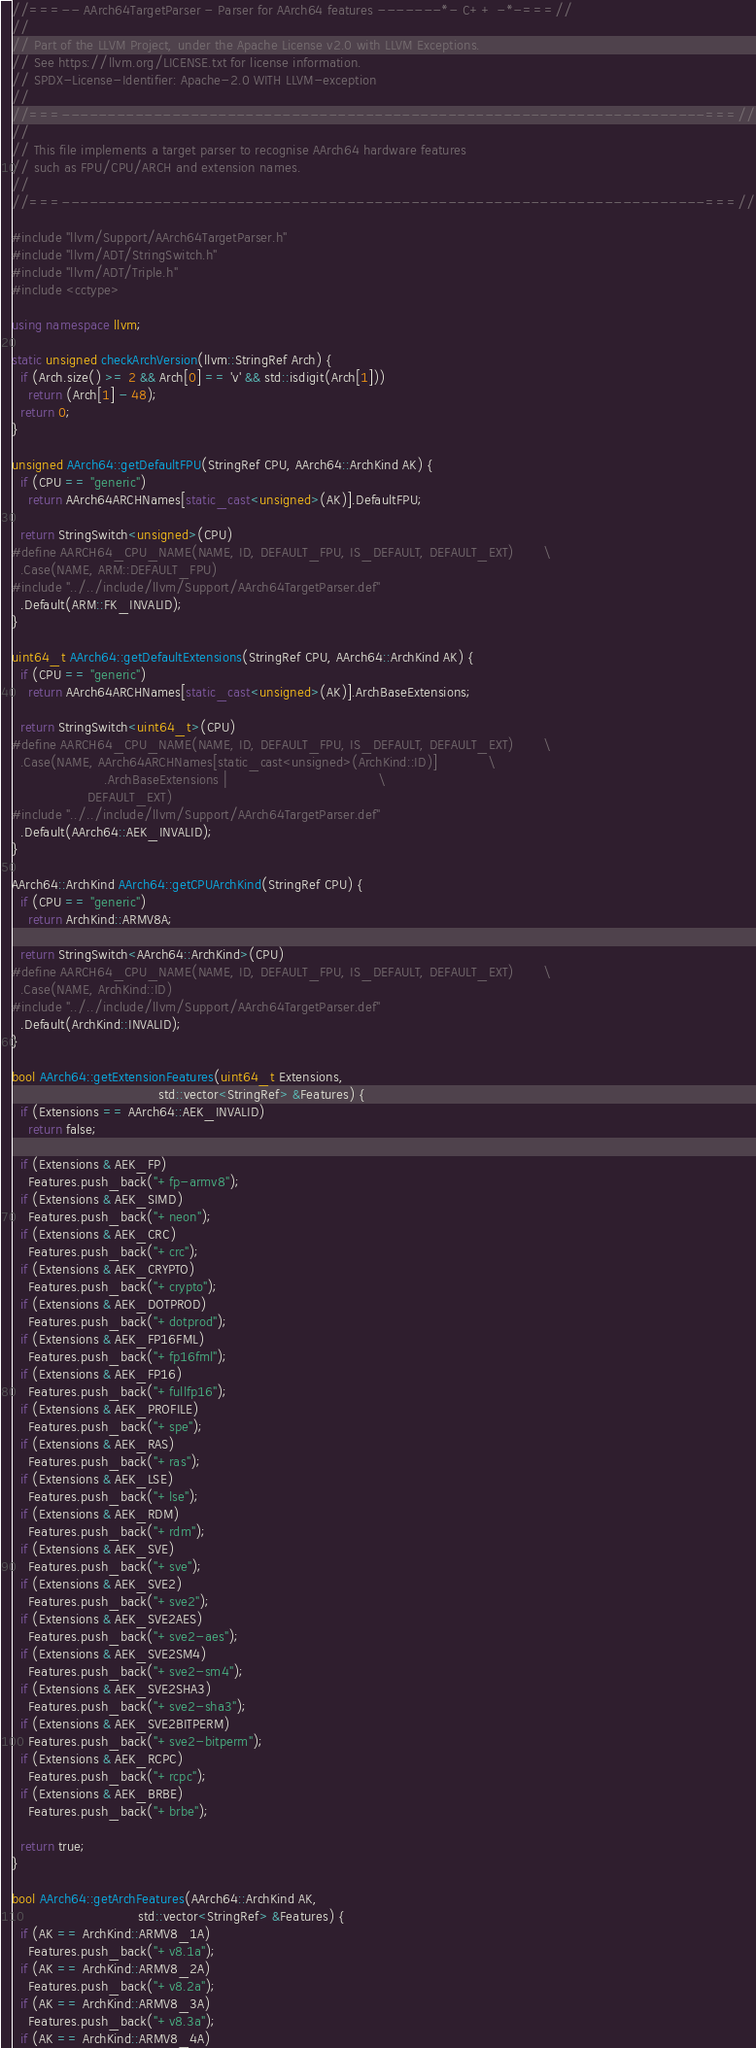Convert code to text. <code><loc_0><loc_0><loc_500><loc_500><_C++_>//===-- AArch64TargetParser - Parser for AArch64 features -------*- C++ -*-===//
//
// Part of the LLVM Project, under the Apache License v2.0 with LLVM Exceptions.
// See https://llvm.org/LICENSE.txt for license information.
// SPDX-License-Identifier: Apache-2.0 WITH LLVM-exception
//
//===----------------------------------------------------------------------===//
//
// This file implements a target parser to recognise AArch64 hardware features
// such as FPU/CPU/ARCH and extension names.
//
//===----------------------------------------------------------------------===//

#include "llvm/Support/AArch64TargetParser.h"
#include "llvm/ADT/StringSwitch.h"
#include "llvm/ADT/Triple.h"
#include <cctype>

using namespace llvm;

static unsigned checkArchVersion(llvm::StringRef Arch) {
  if (Arch.size() >= 2 && Arch[0] == 'v' && std::isdigit(Arch[1]))
    return (Arch[1] - 48);
  return 0;
}

unsigned AArch64::getDefaultFPU(StringRef CPU, AArch64::ArchKind AK) {
  if (CPU == "generic")
    return AArch64ARCHNames[static_cast<unsigned>(AK)].DefaultFPU;

  return StringSwitch<unsigned>(CPU)
#define AARCH64_CPU_NAME(NAME, ID, DEFAULT_FPU, IS_DEFAULT, DEFAULT_EXT)       \
  .Case(NAME, ARM::DEFAULT_FPU)
#include "../../include/llvm/Support/AArch64TargetParser.def"
  .Default(ARM::FK_INVALID);
}

uint64_t AArch64::getDefaultExtensions(StringRef CPU, AArch64::ArchKind AK) {
  if (CPU == "generic")
    return AArch64ARCHNames[static_cast<unsigned>(AK)].ArchBaseExtensions;

  return StringSwitch<uint64_t>(CPU)
#define AARCH64_CPU_NAME(NAME, ID, DEFAULT_FPU, IS_DEFAULT, DEFAULT_EXT)       \
  .Case(NAME, AArch64ARCHNames[static_cast<unsigned>(ArchKind::ID)]            \
                      .ArchBaseExtensions |                                    \
                  DEFAULT_EXT)
#include "../../include/llvm/Support/AArch64TargetParser.def"
  .Default(AArch64::AEK_INVALID);
}

AArch64::ArchKind AArch64::getCPUArchKind(StringRef CPU) {
  if (CPU == "generic")
    return ArchKind::ARMV8A;

  return StringSwitch<AArch64::ArchKind>(CPU)
#define AARCH64_CPU_NAME(NAME, ID, DEFAULT_FPU, IS_DEFAULT, DEFAULT_EXT)       \
  .Case(NAME, ArchKind::ID)
#include "../../include/llvm/Support/AArch64TargetParser.def"
  .Default(ArchKind::INVALID);
}

bool AArch64::getExtensionFeatures(uint64_t Extensions,
                                   std::vector<StringRef> &Features) {
  if (Extensions == AArch64::AEK_INVALID)
    return false;

  if (Extensions & AEK_FP)
    Features.push_back("+fp-armv8");
  if (Extensions & AEK_SIMD)
    Features.push_back("+neon");
  if (Extensions & AEK_CRC)
    Features.push_back("+crc");
  if (Extensions & AEK_CRYPTO)
    Features.push_back("+crypto");
  if (Extensions & AEK_DOTPROD)
    Features.push_back("+dotprod");
  if (Extensions & AEK_FP16FML)
    Features.push_back("+fp16fml");
  if (Extensions & AEK_FP16)
    Features.push_back("+fullfp16");
  if (Extensions & AEK_PROFILE)
    Features.push_back("+spe");
  if (Extensions & AEK_RAS)
    Features.push_back("+ras");
  if (Extensions & AEK_LSE)
    Features.push_back("+lse");
  if (Extensions & AEK_RDM)
    Features.push_back("+rdm");
  if (Extensions & AEK_SVE)
    Features.push_back("+sve");
  if (Extensions & AEK_SVE2)
    Features.push_back("+sve2");
  if (Extensions & AEK_SVE2AES)
    Features.push_back("+sve2-aes");
  if (Extensions & AEK_SVE2SM4)
    Features.push_back("+sve2-sm4");
  if (Extensions & AEK_SVE2SHA3)
    Features.push_back("+sve2-sha3");
  if (Extensions & AEK_SVE2BITPERM)
    Features.push_back("+sve2-bitperm");
  if (Extensions & AEK_RCPC)
    Features.push_back("+rcpc");
  if (Extensions & AEK_BRBE)
    Features.push_back("+brbe");

  return true;
}

bool AArch64::getArchFeatures(AArch64::ArchKind AK,
                              std::vector<StringRef> &Features) {
  if (AK == ArchKind::ARMV8_1A)
    Features.push_back("+v8.1a");
  if (AK == ArchKind::ARMV8_2A)
    Features.push_back("+v8.2a");
  if (AK == ArchKind::ARMV8_3A)
    Features.push_back("+v8.3a");
  if (AK == ArchKind::ARMV8_4A)</code> 